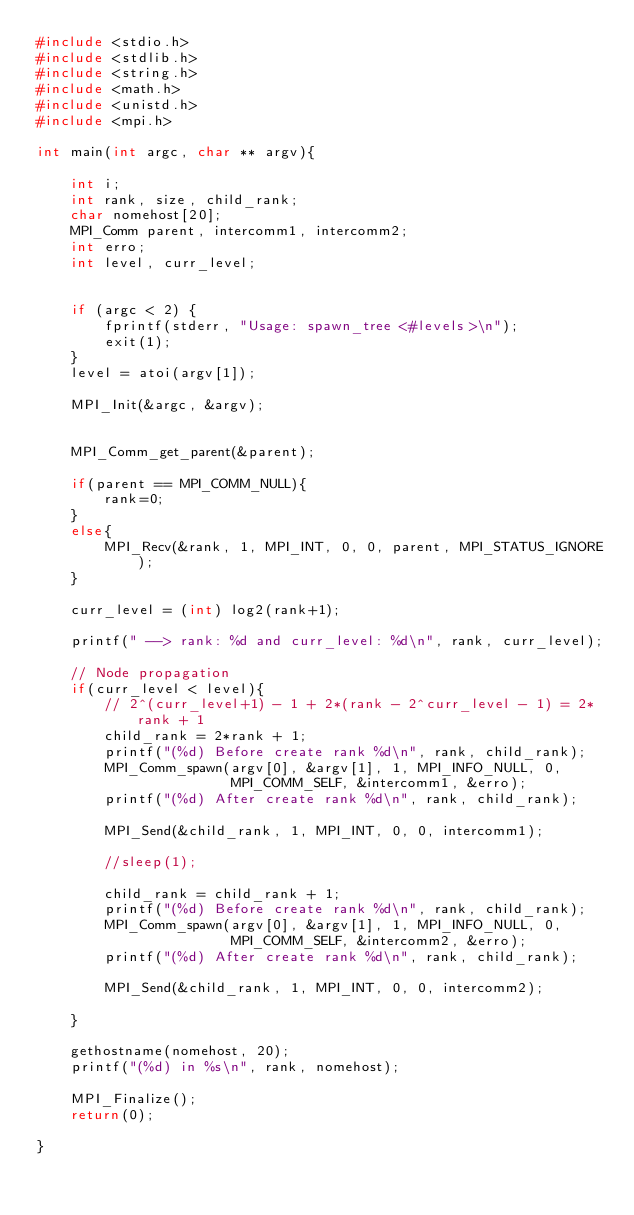Convert code to text. <code><loc_0><loc_0><loc_500><loc_500><_C_>#include <stdio.h>
#include <stdlib.h>
#include <string.h>
#include <math.h>
#include <unistd.h>
#include <mpi.h>

int main(int argc, char ** argv){

    int i;
    int rank, size, child_rank;
    char nomehost[20];
    MPI_Comm parent, intercomm1, intercomm2;
    int erro;
    int level, curr_level;


    if (argc < 2) {
        fprintf(stderr, "Usage: spawn_tree <#levels>\n");
        exit(1);
    }
    level = atoi(argv[1]);

    MPI_Init(&argc, &argv);


    MPI_Comm_get_parent(&parent);

    if(parent == MPI_COMM_NULL){
        rank=0;
    }
    else{
        MPI_Recv(&rank, 1, MPI_INT, 0, 0, parent, MPI_STATUS_IGNORE);
    }

    curr_level = (int) log2(rank+1);

    printf(" --> rank: %d and curr_level: %d\n", rank, curr_level);

    // Node propagation
    if(curr_level < level){
        // 2^(curr_level+1) - 1 + 2*(rank - 2^curr_level - 1) = 2*rank + 1
        child_rank = 2*rank + 1;
        printf("(%d) Before create rank %d\n", rank, child_rank);
        MPI_Comm_spawn(argv[0], &argv[1], 1, MPI_INFO_NULL, 0,
                       MPI_COMM_SELF, &intercomm1, &erro);
        printf("(%d) After create rank %d\n", rank, child_rank);

        MPI_Send(&child_rank, 1, MPI_INT, 0, 0, intercomm1);

        //sleep(1);

        child_rank = child_rank + 1;
        printf("(%d) Before create rank %d\n", rank, child_rank);
        MPI_Comm_spawn(argv[0], &argv[1], 1, MPI_INFO_NULL, 0,
                       MPI_COMM_SELF, &intercomm2, &erro);
        printf("(%d) After create rank %d\n", rank, child_rank);

        MPI_Send(&child_rank, 1, MPI_INT, 0, 0, intercomm2);

    }

    gethostname(nomehost, 20);
    printf("(%d) in %s\n", rank, nomehost);

    MPI_Finalize();
    return(0);

}
</code> 